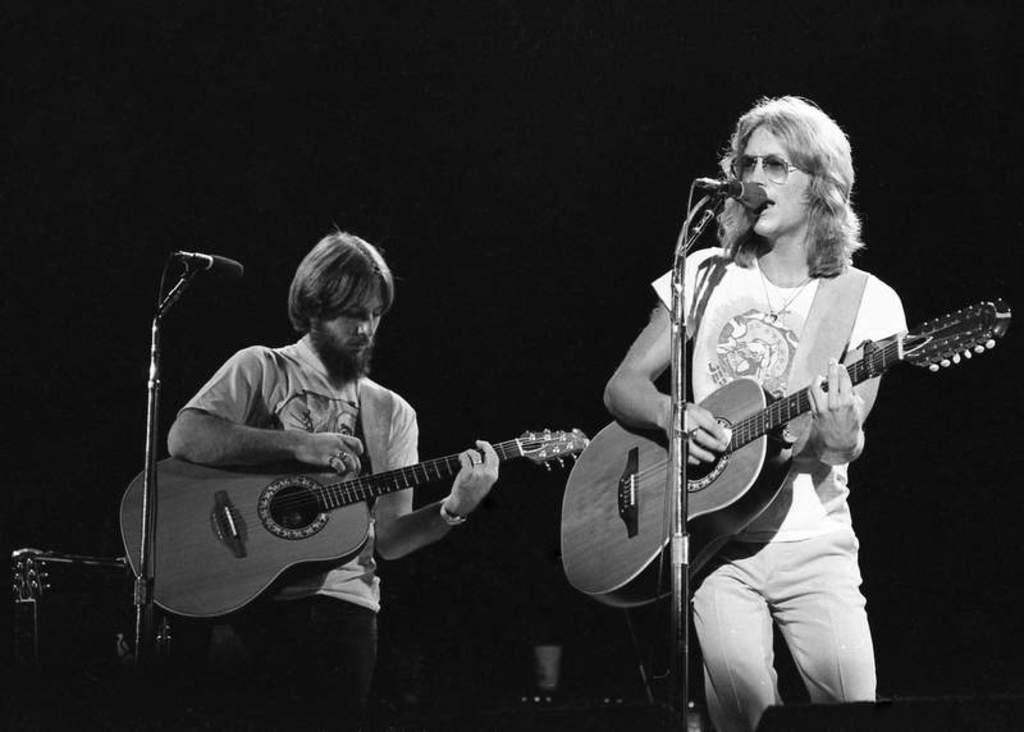How many people are in the picture? There are two men in the picture. What are the men doing in the picture? The men are standing and holding guitars. What objects are in front of the men? The men have microphones in front of them. What type of list can be seen in the picture? There is no list present in the picture. What is the color of the copper in the picture? There is no copper present in the picture. 